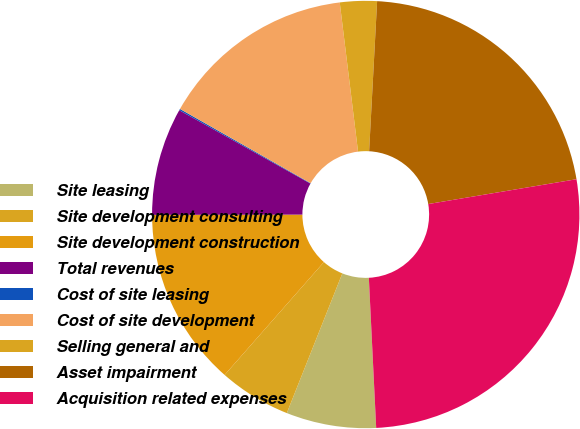Convert chart. <chart><loc_0><loc_0><loc_500><loc_500><pie_chart><fcel>Site leasing<fcel>Site development consulting<fcel>Site development construction<fcel>Total revenues<fcel>Cost of site leasing<fcel>Cost of site development<fcel>Selling general and<fcel>Asset impairment<fcel>Acquisition related expenses<nl><fcel>6.8%<fcel>5.46%<fcel>13.49%<fcel>8.14%<fcel>0.11%<fcel>14.83%<fcel>2.79%<fcel>21.51%<fcel>26.86%<nl></chart> 